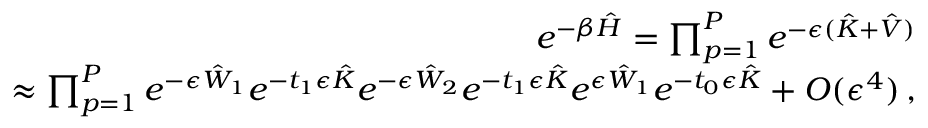Convert formula to latex. <formula><loc_0><loc_0><loc_500><loc_500>\begin{array} { r l r } & { e ^ { - \beta \hat { H } } = \prod _ { p = 1 } ^ { P } e ^ { - \epsilon ( \hat { K } + \hat { V } ) } } \\ & { \approx \prod _ { p = 1 } ^ { P } e ^ { - \epsilon \hat { W } _ { 1 } } e ^ { - t _ { 1 } \epsilon \hat { K } } e ^ { - \epsilon \hat { W } _ { 2 } } e ^ { - t _ { 1 } \epsilon \hat { K } } e ^ { \epsilon \hat { W } _ { 1 } } e ^ { - t _ { 0 } \epsilon \hat { K } } + O ( \epsilon ^ { 4 } ) \, , } \end{array}</formula> 